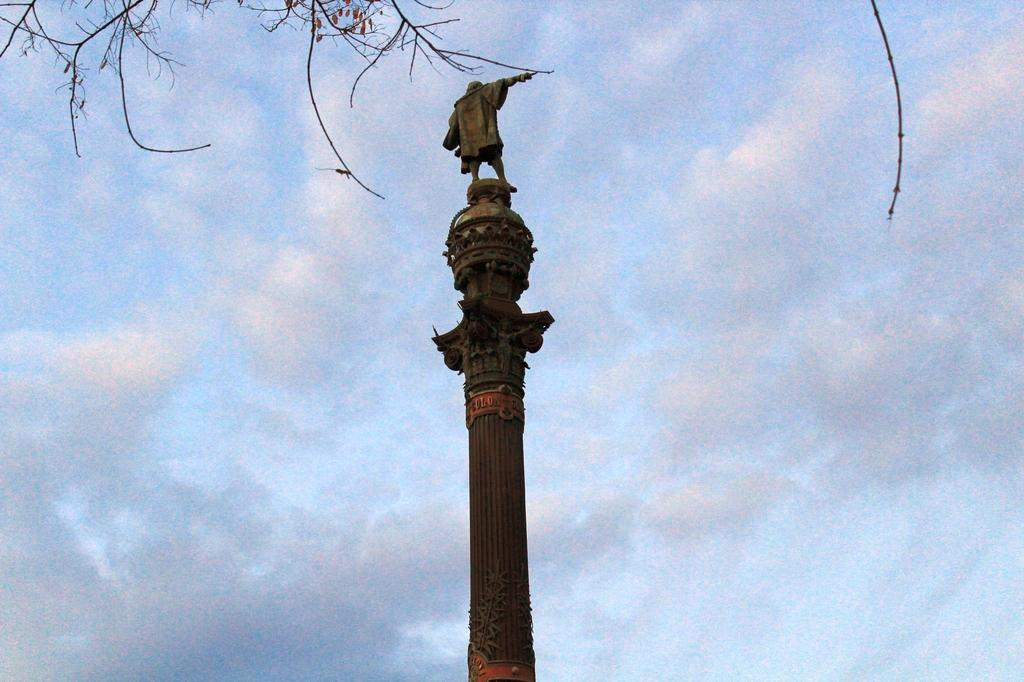What is the main object in the image? There is a huge pole in the image. What colors can be seen on the pole? The pole is black and orange in color. What is on top of the pole? There is a statue of a person on the pole. What can be seen in the background of the image? There is a tree and the sky visible in the background of the image. What is the price of the folding chair in the image? There is no folding chair present in the image, so it is not possible to determine its price. 